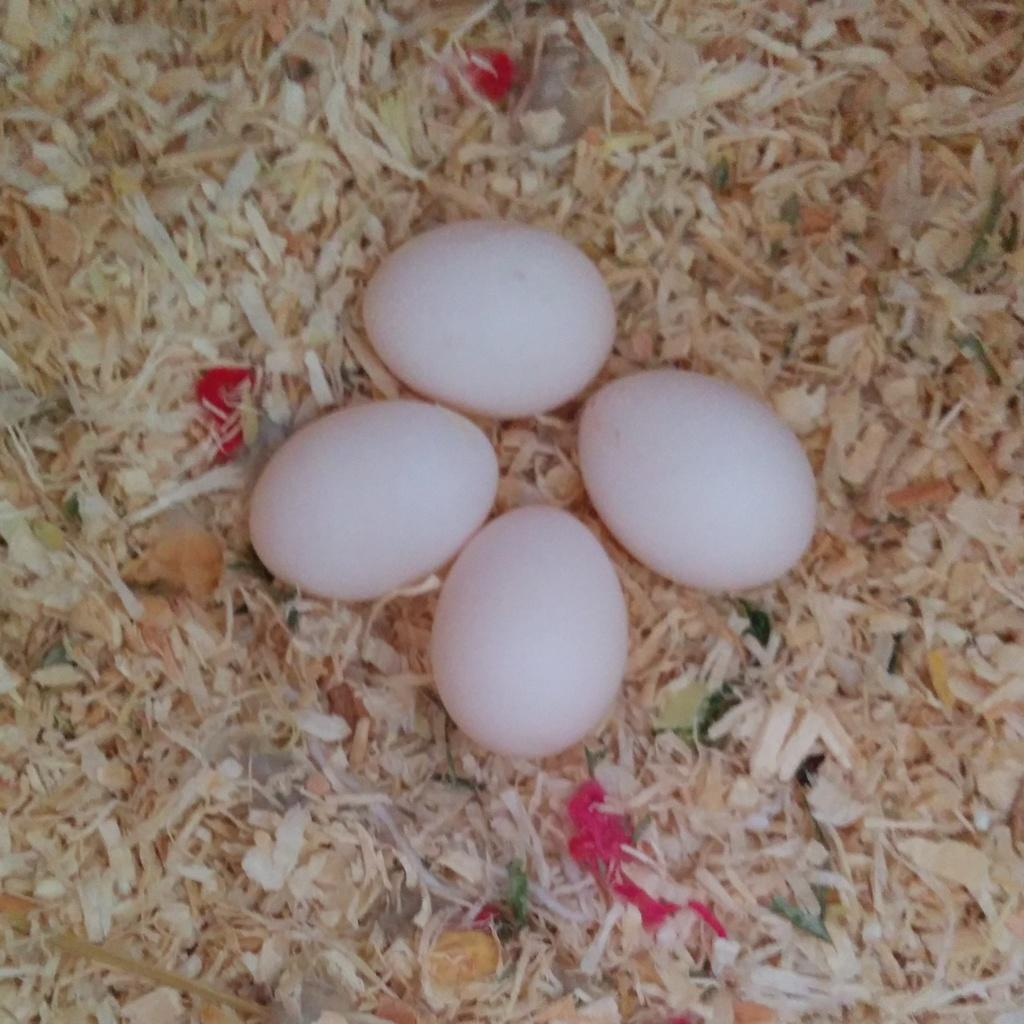How many eggs are visible in the image? There are four eggs in the image. What is the color of the surface on which the eggs are placed? The eggs are on a cream-colored surface. What type of wilderness can be seen in the background of the image? There is no wilderness visible in the image; it only features four eggs on a cream-colored surface. 